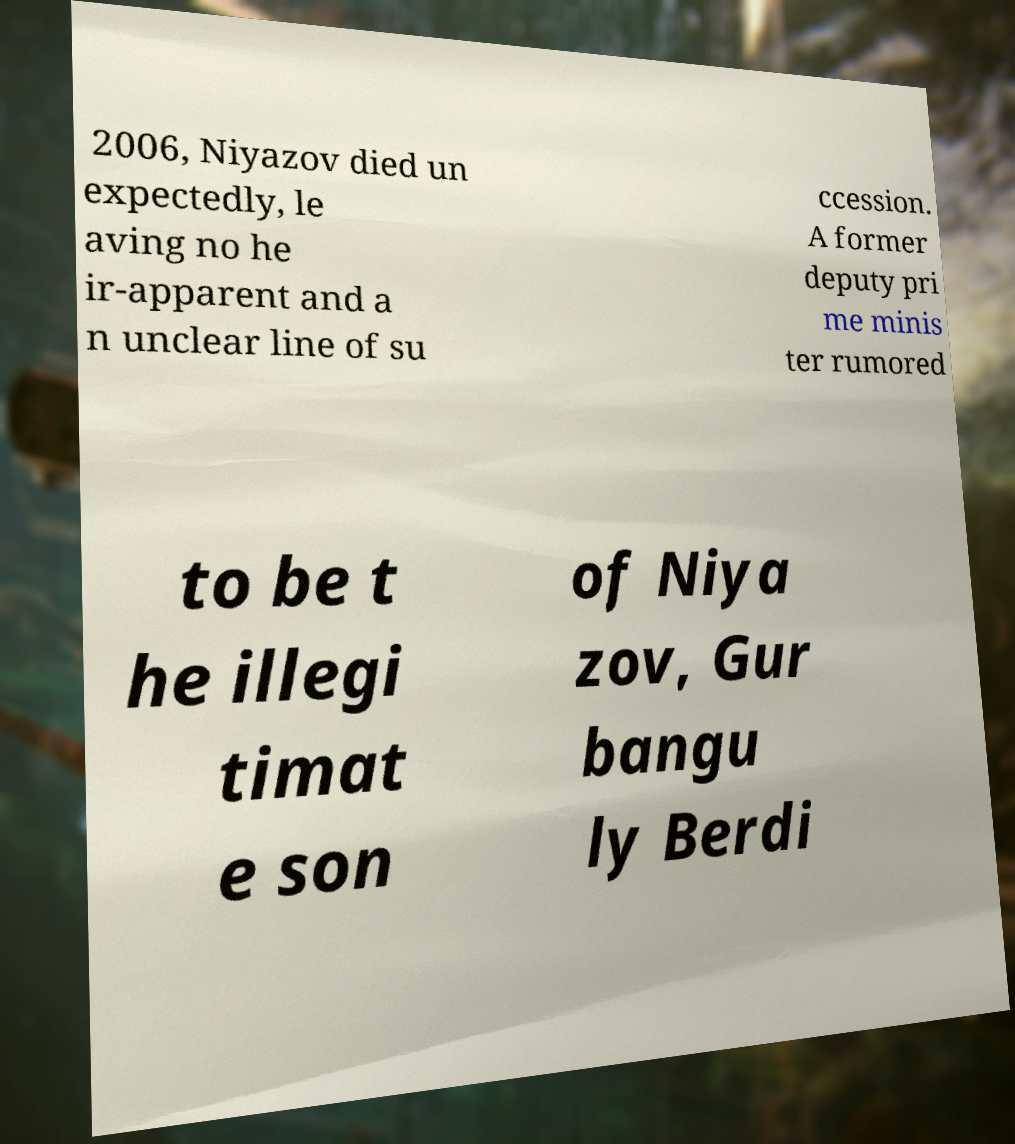For documentation purposes, I need the text within this image transcribed. Could you provide that? 2006, Niyazov died un expectedly, le aving no he ir-apparent and a n unclear line of su ccession. A former deputy pri me minis ter rumored to be t he illegi timat e son of Niya zov, Gur bangu ly Berdi 